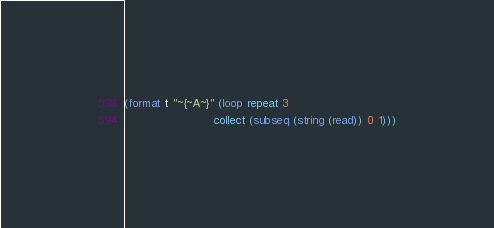<code> <loc_0><loc_0><loc_500><loc_500><_Lisp_>(format t "~{~A~}" (loop repeat 3
                         collect (subseq (string (read)) 0 1)))</code> 